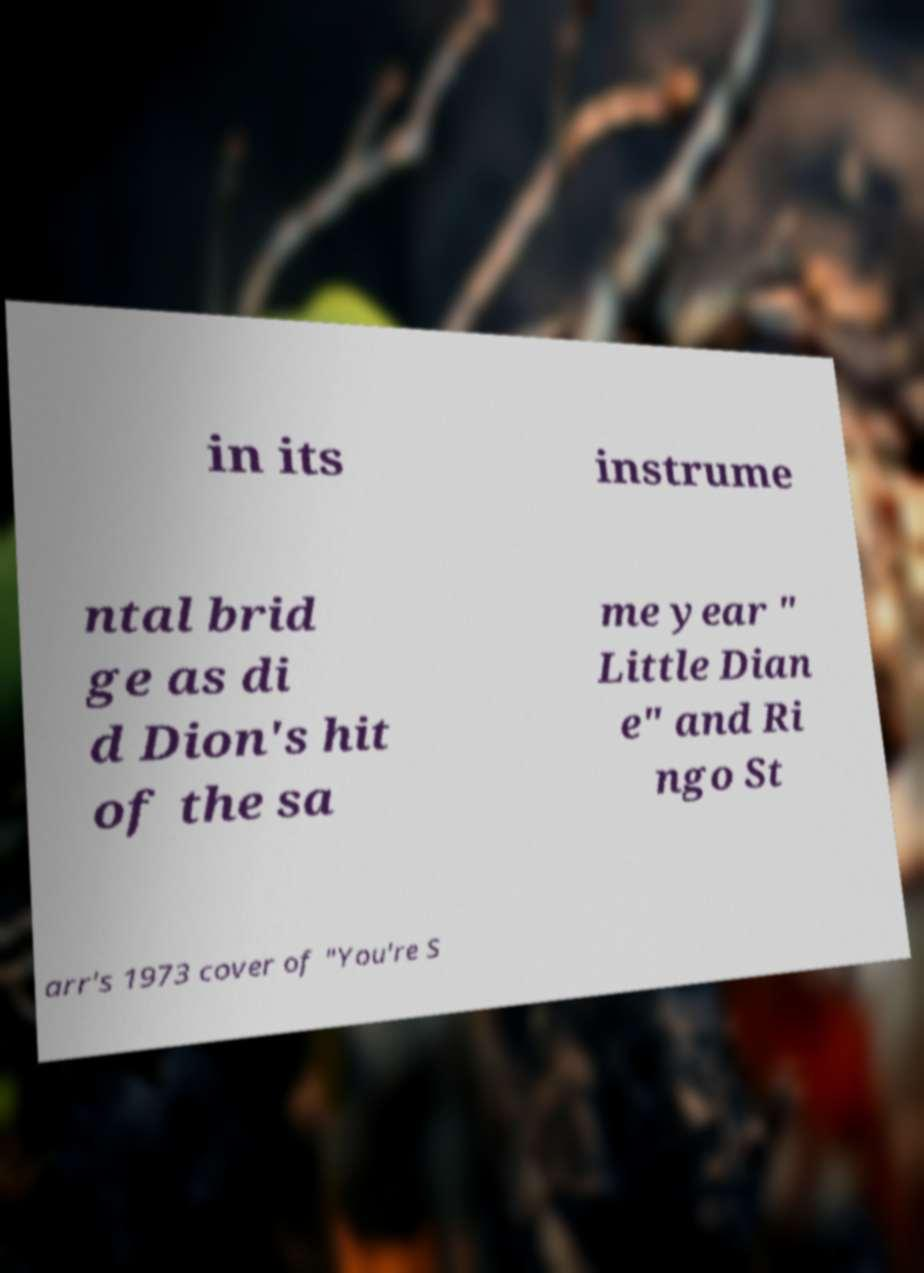There's text embedded in this image that I need extracted. Can you transcribe it verbatim? in its instrume ntal brid ge as di d Dion's hit of the sa me year " Little Dian e" and Ri ngo St arr's 1973 cover of "You're S 